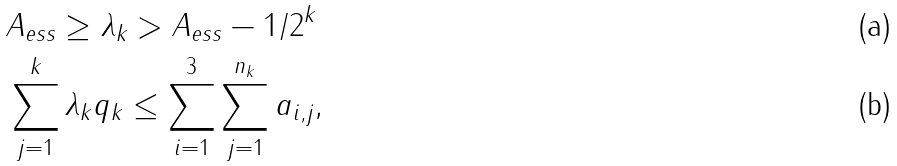<formula> <loc_0><loc_0><loc_500><loc_500>& \| A \| _ { e s s } \geq \lambda _ { k } > \| A \| _ { e s s } - 1 / 2 ^ { k } \\ & \sum _ { j = 1 } ^ { k } \lambda _ { k } q _ { k } \leq \sum _ { i = 1 } ^ { 3 } \sum _ { j = 1 } ^ { n _ { k } } a _ { i , j } ,</formula> 